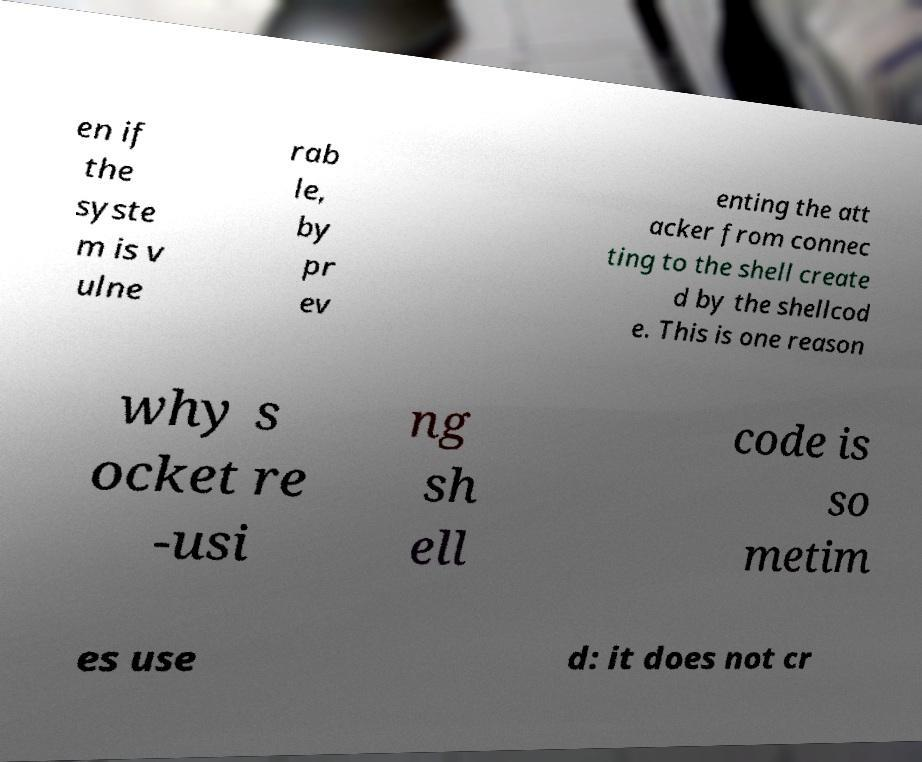For documentation purposes, I need the text within this image transcribed. Could you provide that? en if the syste m is v ulne rab le, by pr ev enting the att acker from connec ting to the shell create d by the shellcod e. This is one reason why s ocket re -usi ng sh ell code is so metim es use d: it does not cr 